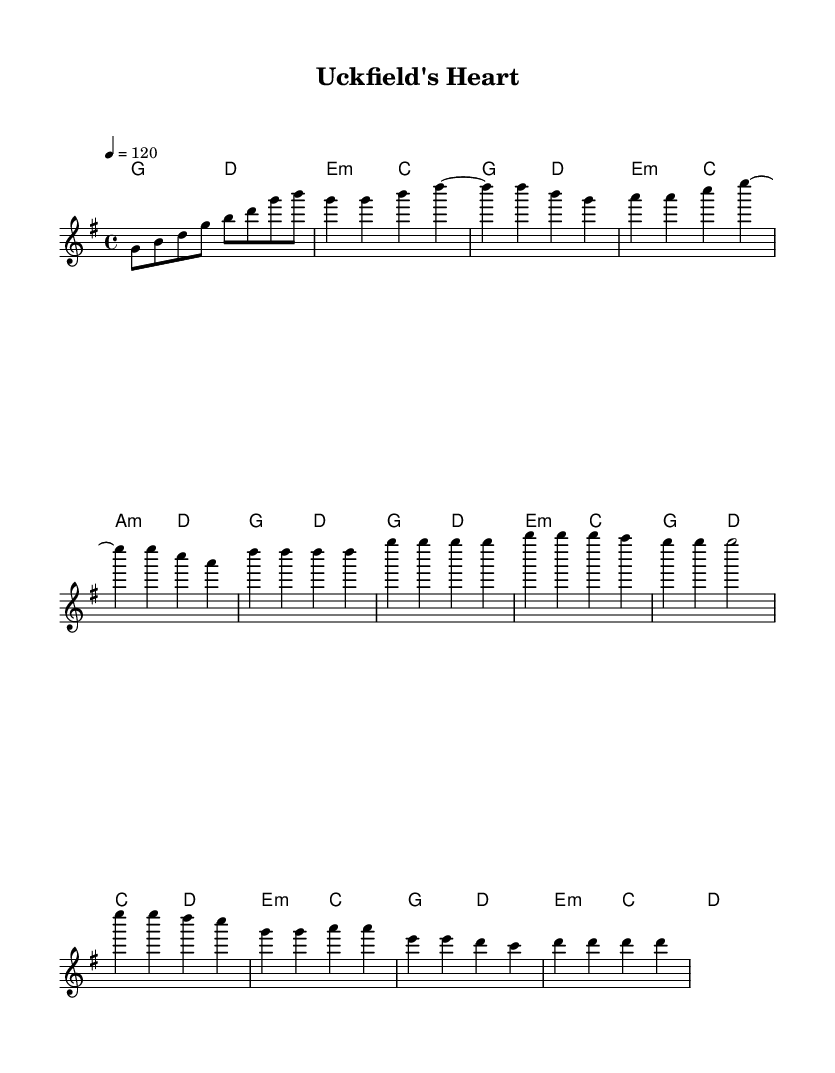What is the key signature of this music? The key signature is G major, which has one sharp (F#). This can be determined by looking at the key signature indicated at the beginning of the score.
Answer: G major What is the time signature of the piece? The time signature is 4/4, which means there are four beats per measure and the quarter note receives one beat. This is indicated at the beginning of the score with the time signature notation.
Answer: 4/4 What is the tempo marking given in the sheet music? The tempo marking is quarter note equals 120 BPM. This is indicated in the tempo section at the start of the score.
Answer: 120 How many measures are there in the chorus section? The chorus section consists of four measures. Counting the bars in the designated chorus area will confirm this.
Answer: 4 What type of chord is used in the introduction? The introduction features a G major chord followed by a D major chord. These chords can be identified in the harmonies part of the score.
Answer: G major How does the bridge differ harmonically from the verse? The bridge introduces E minor and C major chords, contrasting with the G major and D major used in the verse. This can be deduced by comparing the harmonic structures in both sections.
Answer: E minor and C major 